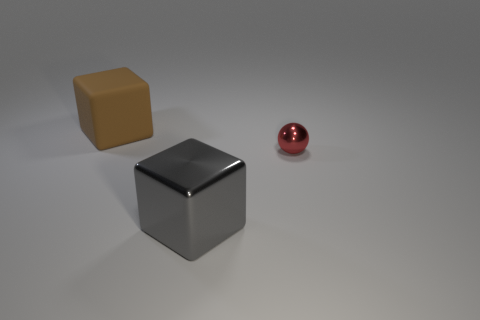What number of large brown blocks are there?
Offer a terse response. 1. How many large objects are made of the same material as the large gray block?
Your answer should be very brief. 0. There is a gray metal thing that is the same shape as the brown rubber object; what is its size?
Give a very brief answer. Large. What is the material of the gray thing?
Provide a short and direct response. Metal. What material is the cube in front of the big object behind the large object that is on the right side of the big brown cube?
Offer a terse response. Metal. Is there anything else that is the same shape as the small thing?
Offer a very short reply. No. What color is the other big metal thing that is the same shape as the brown thing?
Your answer should be compact. Gray. There is a large cube in front of the small red shiny ball; does it have the same color as the object behind the small metallic sphere?
Your answer should be very brief. No. Is the number of small red spheres that are behind the tiny thing greater than the number of large brown rubber objects?
Provide a succinct answer. No. What number of other things are there of the same size as the brown matte thing?
Provide a succinct answer. 1. 